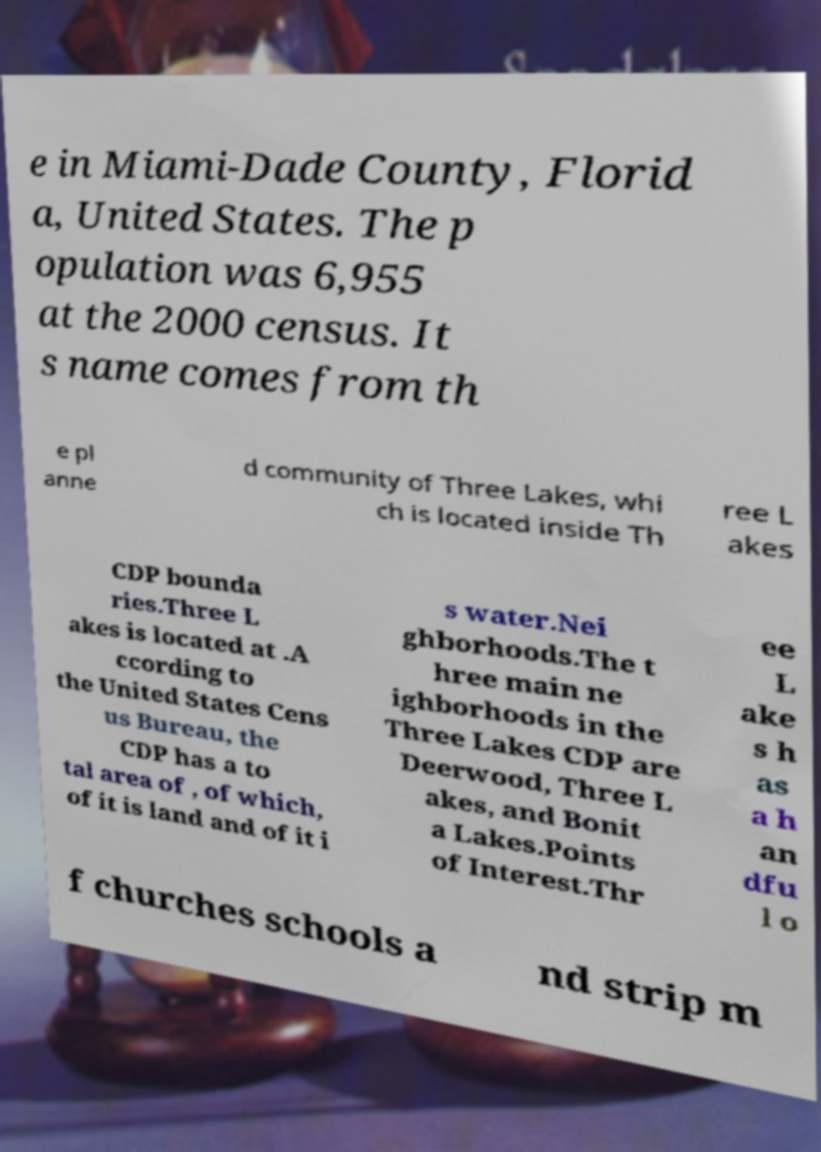For documentation purposes, I need the text within this image transcribed. Could you provide that? e in Miami-Dade County, Florid a, United States. The p opulation was 6,955 at the 2000 census. It s name comes from th e pl anne d community of Three Lakes, whi ch is located inside Th ree L akes CDP bounda ries.Three L akes is located at .A ccording to the United States Cens us Bureau, the CDP has a to tal area of , of which, of it is land and of it i s water.Nei ghborhoods.The t hree main ne ighborhoods in the Three Lakes CDP are Deerwood, Three L akes, and Bonit a Lakes.Points of Interest.Thr ee L ake s h as a h an dfu l o f churches schools a nd strip m 